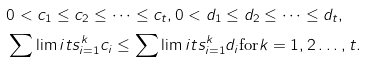<formula> <loc_0><loc_0><loc_500><loc_500>& 0 < c _ { 1 } \leq { c _ { 2 } } \leq \cdots \leq { c _ { t } } , 0 < d _ { 1 } \leq { d _ { 2 } } \leq \cdots \leq { d _ { t } } , \\ & \sum \lim i t s _ { i = 1 } ^ { k } c _ { i } \leq \sum \lim i t s _ { i = 1 } ^ { k } d _ { i } \text {for} k = 1 , 2 \dots , t .</formula> 